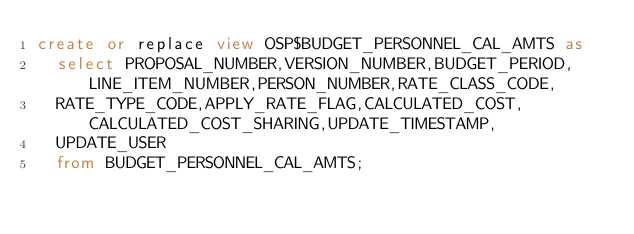Convert code to text. <code><loc_0><loc_0><loc_500><loc_500><_SQL_>create or replace view OSP$BUDGET_PERSONNEL_CAL_AMTS as 
	select PROPOSAL_NUMBER,VERSION_NUMBER,BUDGET_PERIOD,LINE_ITEM_NUMBER,PERSON_NUMBER,RATE_CLASS_CODE,
	RATE_TYPE_CODE,APPLY_RATE_FLAG,CALCULATED_COST,CALCULATED_COST_SHARING,UPDATE_TIMESTAMP,
	UPDATE_USER
	from BUDGET_PERSONNEL_CAL_AMTS;</code> 